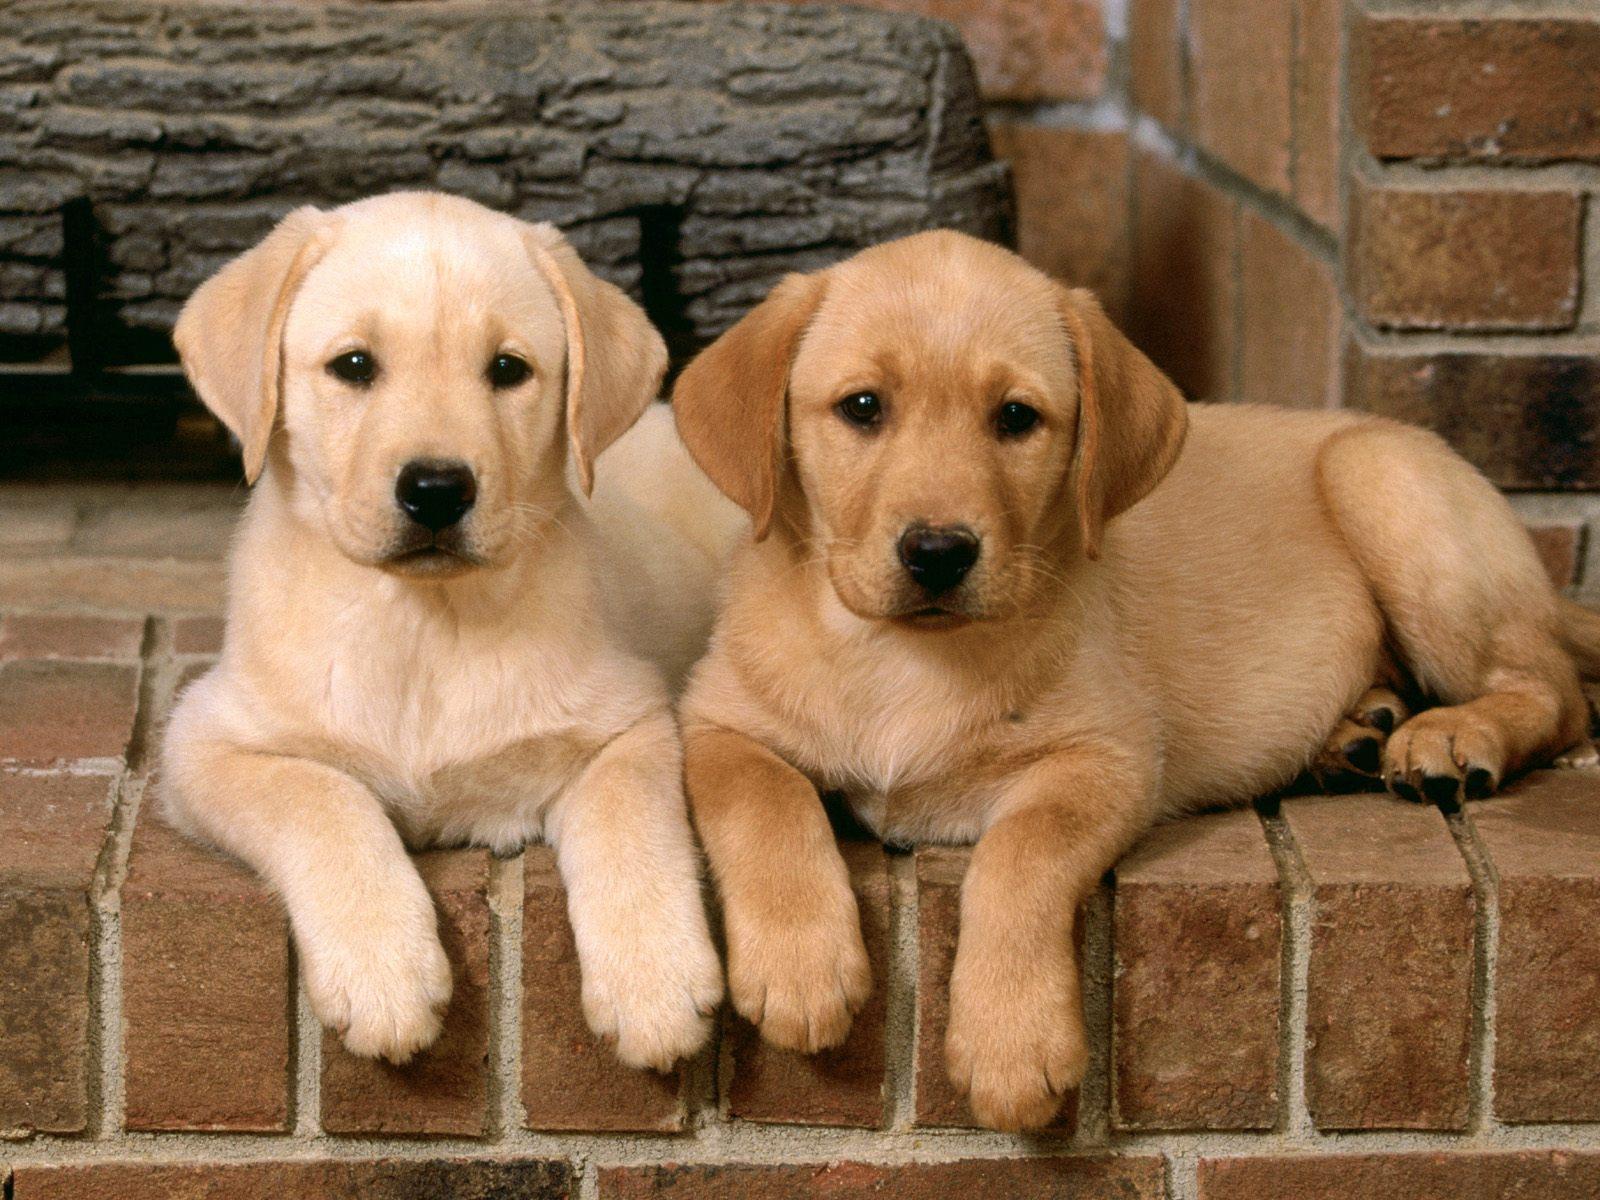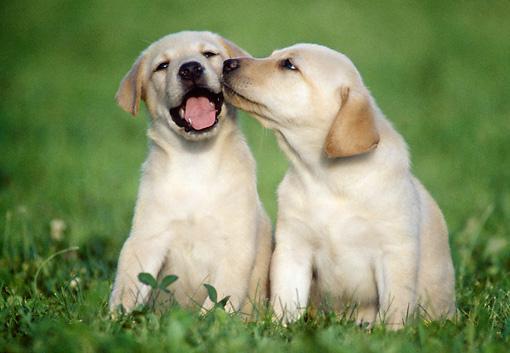The first image is the image on the left, the second image is the image on the right. For the images shown, is this caption "One image shows side-by-side puppies posed with front paws dangling over an edge, and the other image shows one blond pup in position to lick the blond pup next to it." true? Answer yes or no. Yes. 